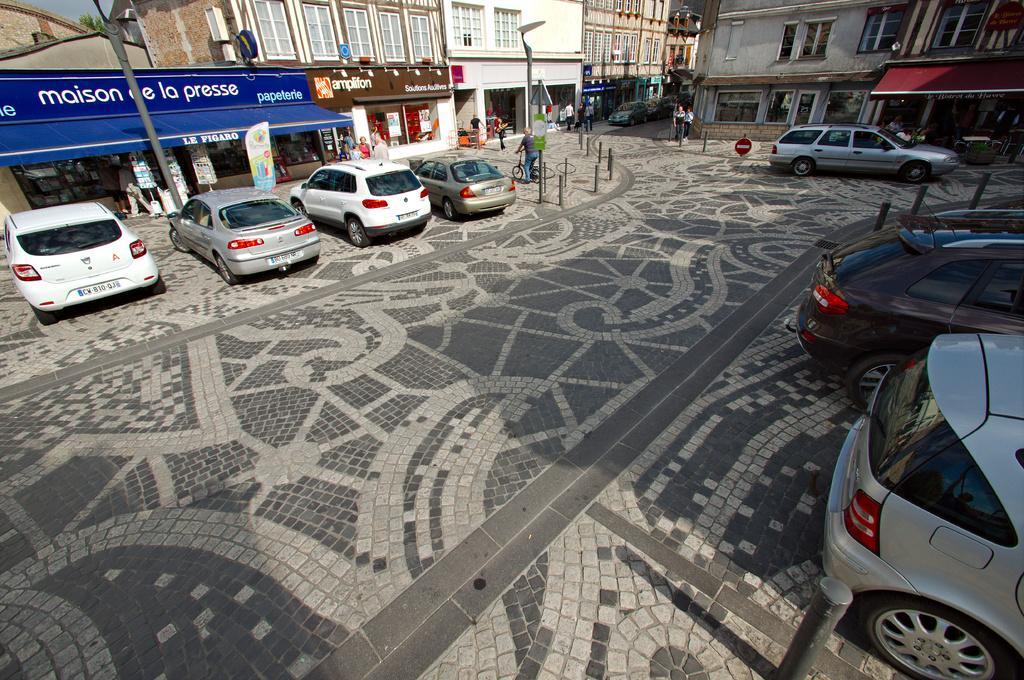How would you summarize this image in a sentence or two? It is a street there are many vehicles parked in front of the stores and some people are walking beside the vehicles and above the stores there are beautiful buildings with many windows. 